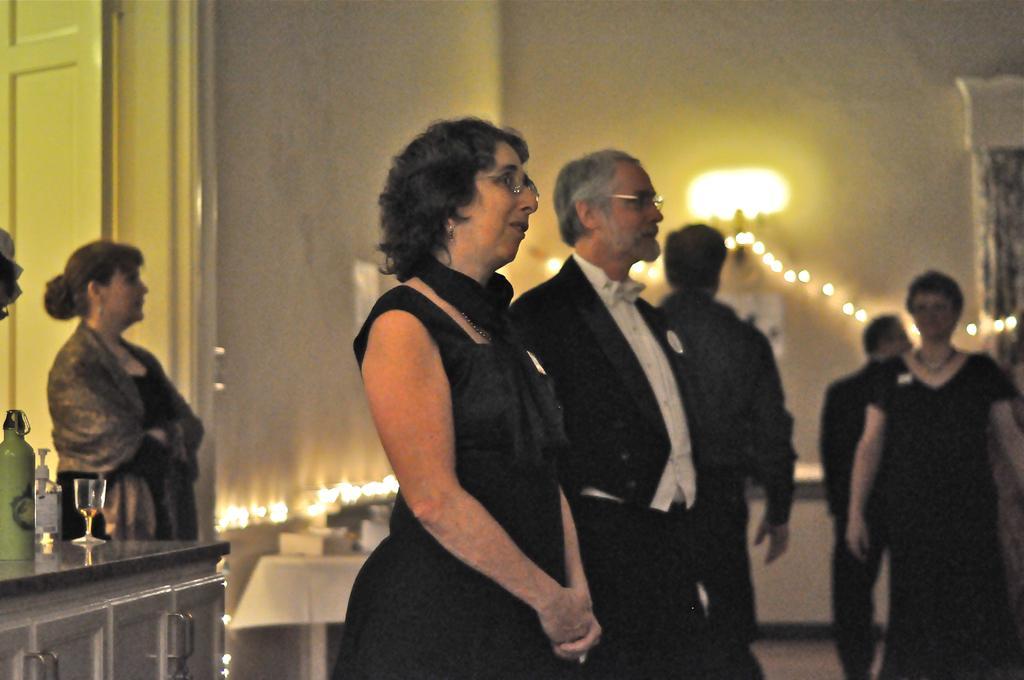How would you summarize this image in a sentence or two? In this image there are so many people standing in room, beside them there is a table with bottle and glass also there are some lights on the wall. 